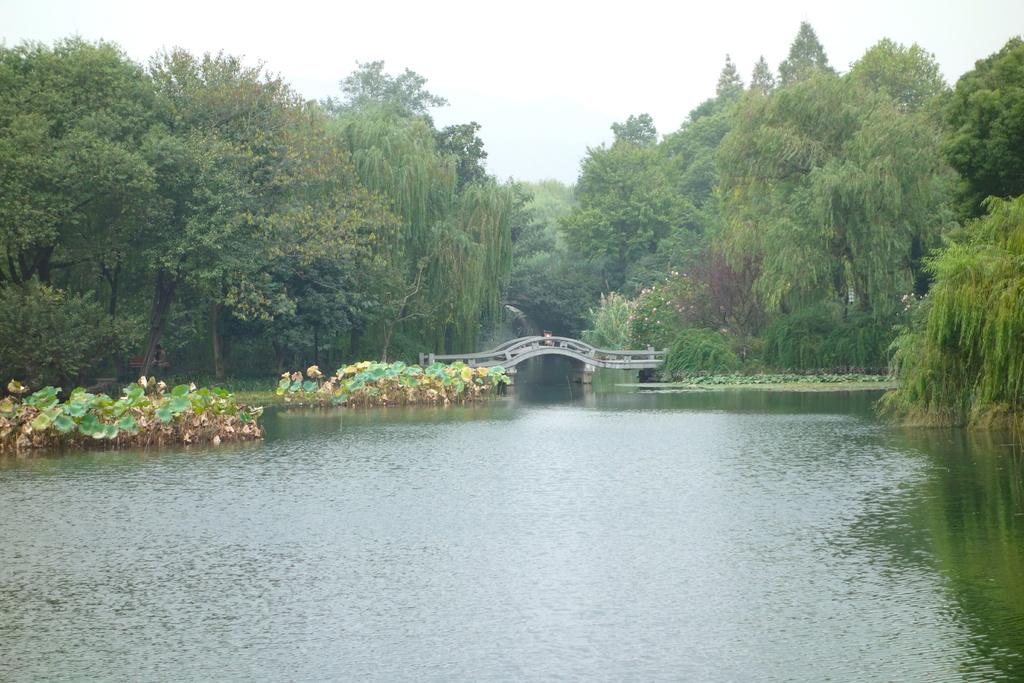What is the main subject of the image? The main subject of the image is plants in the water. What can be seen behind the plants? There is a bridge visible behind the plants. What type of vegetation is in the background of the image? There are trees in the background of the image. What is visible in the sky in the image? The sky is visible in the background of the image. What type of crime is being committed in the image? There is no indication of any crime being committed in the image. The image features plants in the water, a bridge, trees, and the sky. 